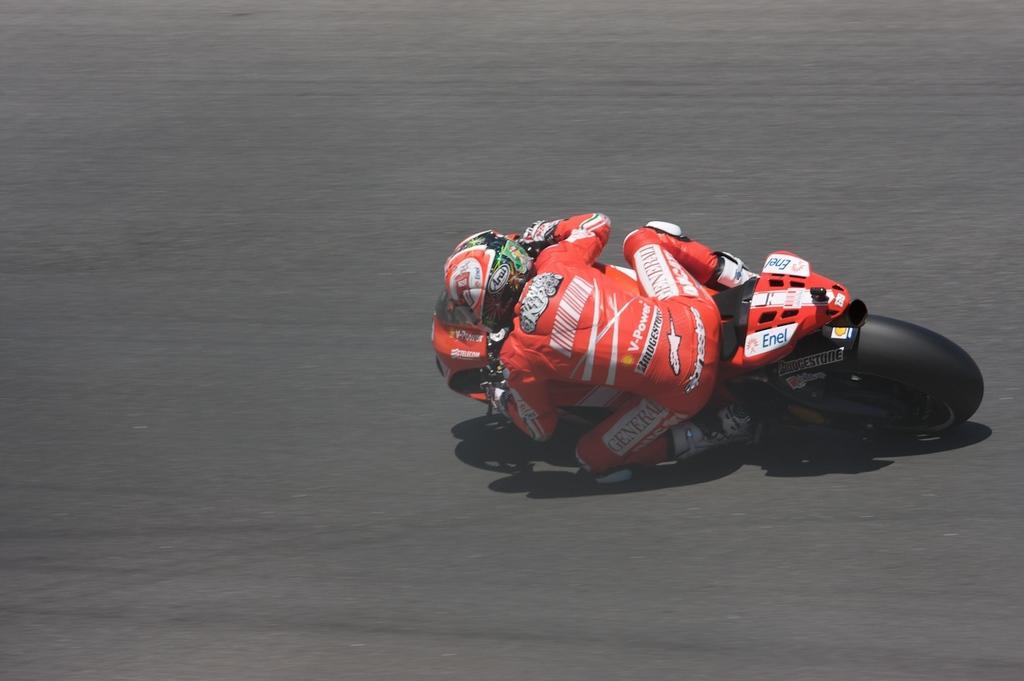Describe this image in one or two sentences. In this picture there is a man who is wearing helmet, t-shirt, gloves, trouser and shoe. He is riding a bike on the road. 